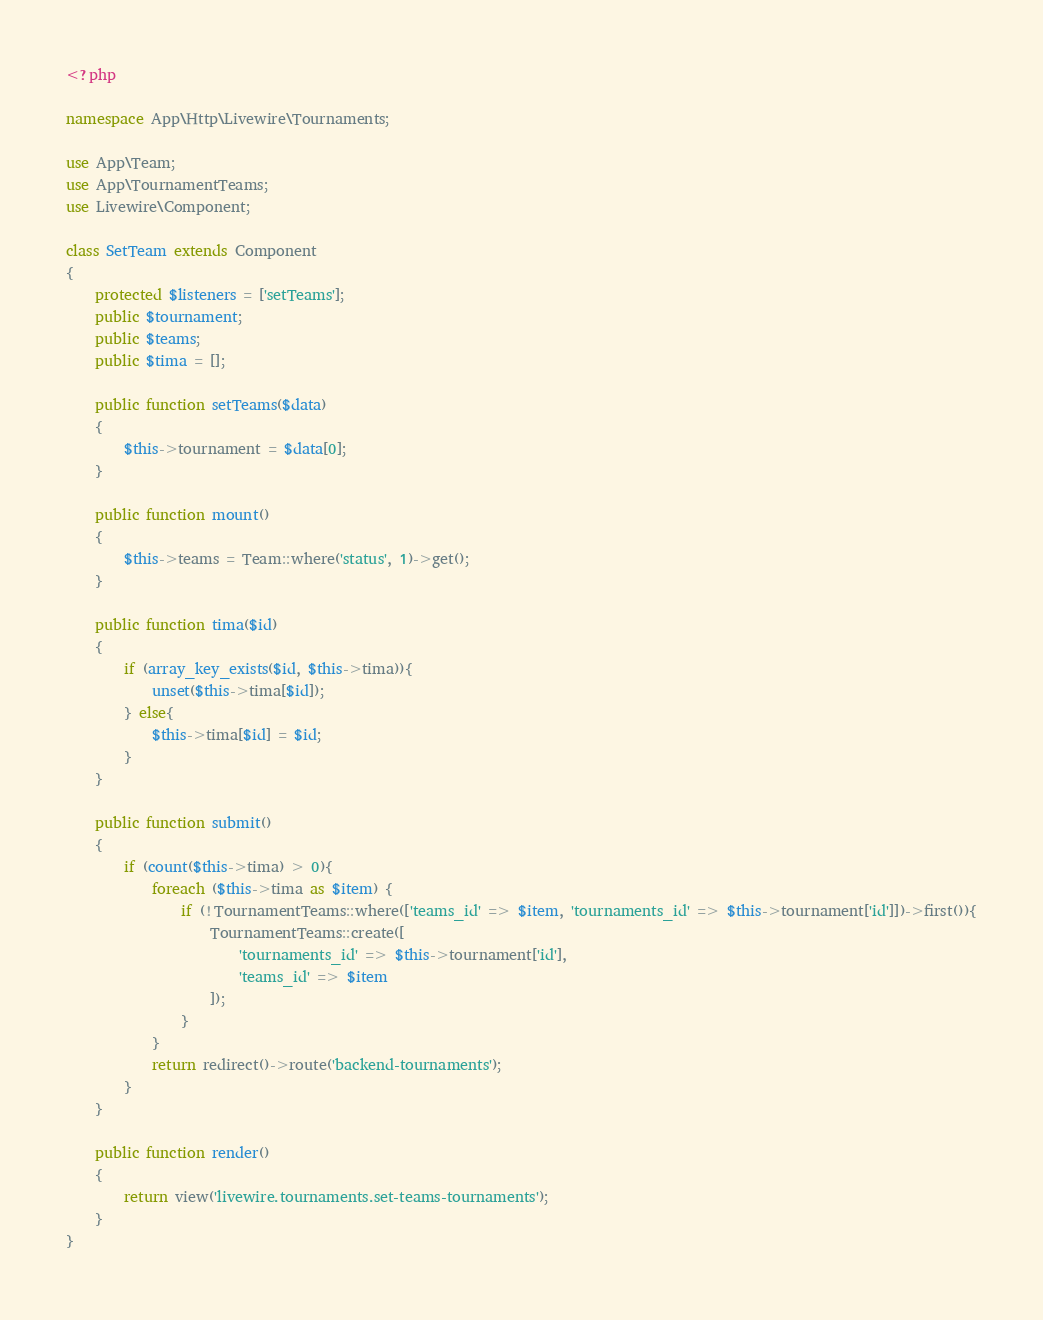<code> <loc_0><loc_0><loc_500><loc_500><_PHP_><?php

namespace App\Http\Livewire\Tournaments;

use App\Team;
use App\TournamentTeams;
use Livewire\Component;

class SetTeam extends Component
{
    protected $listeners = ['setTeams'];
    public $tournament;
    public $teams;
    public $tima = [];

    public function setTeams($data)
    {
        $this->tournament = $data[0];
    }

    public function mount()
    {
        $this->teams = Team::where('status', 1)->get();
    }

    public function tima($id)
    {
        if (array_key_exists($id, $this->tima)){
            unset($this->tima[$id]);
        } else{
            $this->tima[$id] = $id;
        }
    }

    public function submit()
    {
        if (count($this->tima) > 0){
            foreach ($this->tima as $item) {
                if (!TournamentTeams::where(['teams_id' => $item, 'tournaments_id' => $this->tournament['id']])->first()){
                    TournamentTeams::create([
                        'tournaments_id' => $this->tournament['id'],
                        'teams_id' => $item
                    ]);
                }
            }
            return redirect()->route('backend-tournaments');
        }
    }

    public function render()
    {
        return view('livewire.tournaments.set-teams-tournaments');
    }
}
</code> 